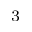Convert formula to latex. <formula><loc_0><loc_0><loc_500><loc_500>_ { 3 }</formula> 